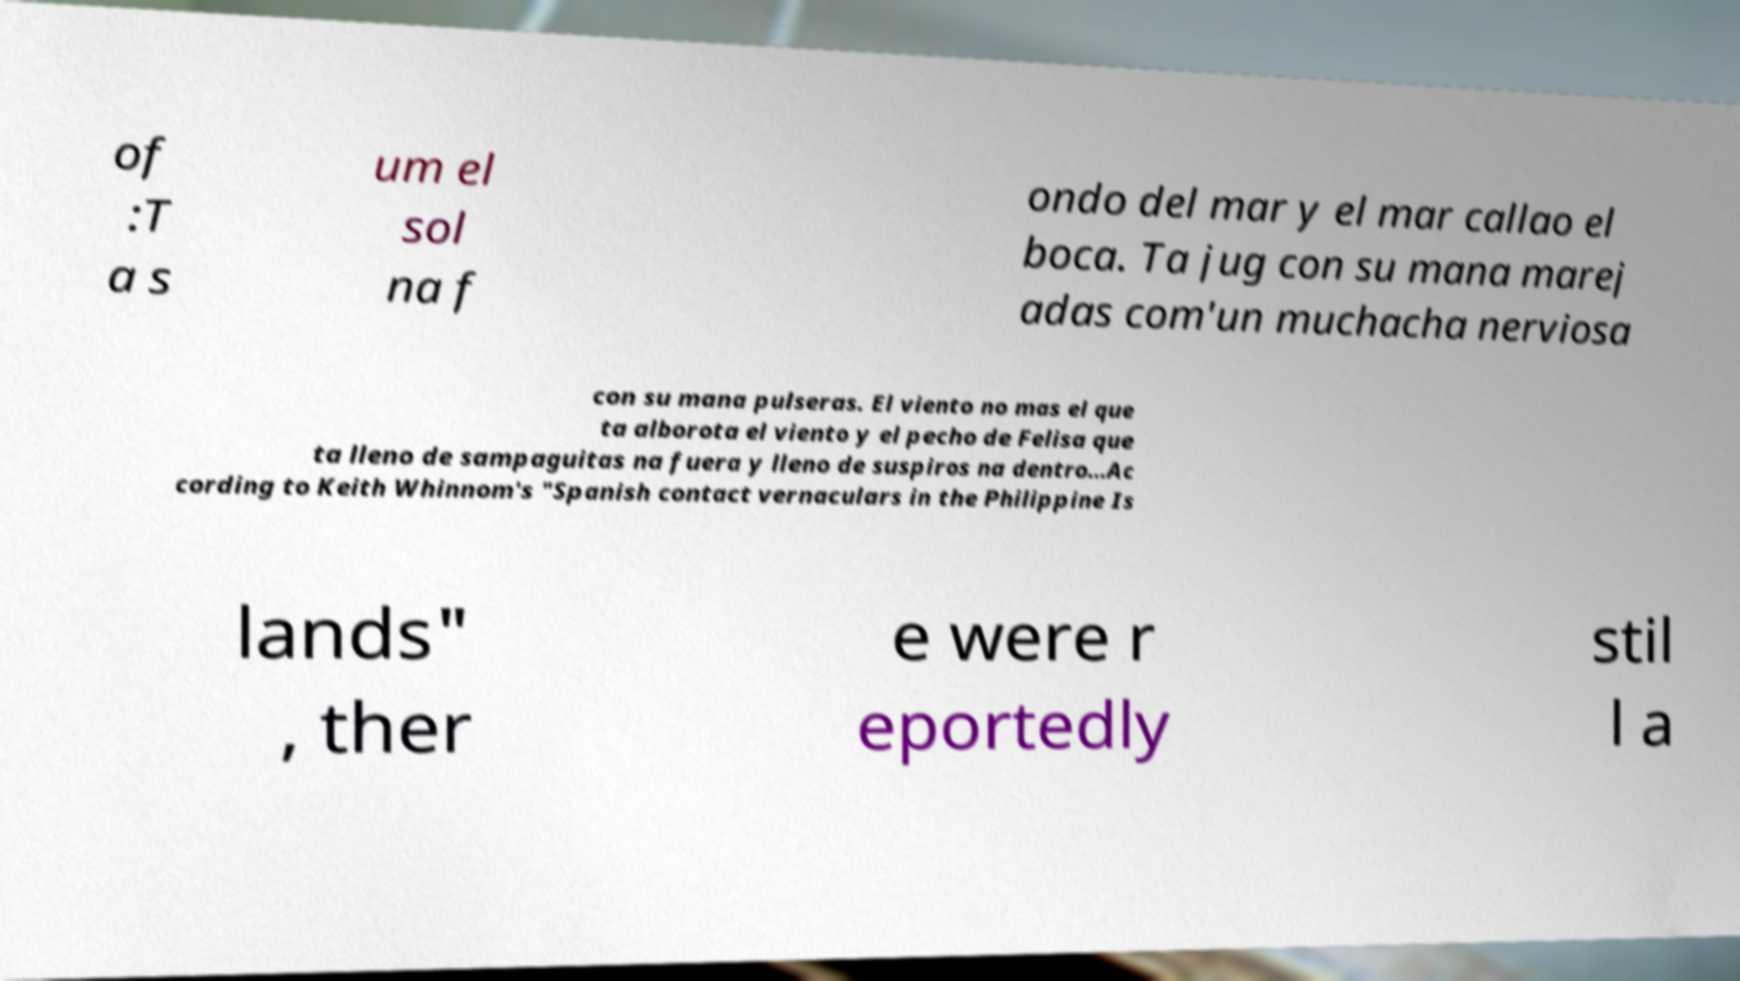Can you accurately transcribe the text from the provided image for me? of :T a s um el sol na f ondo del mar y el mar callao el boca. Ta jug con su mana marej adas com'un muchacha nerviosa con su mana pulseras. El viento no mas el que ta alborota el viento y el pecho de Felisa que ta lleno de sampaguitas na fuera y lleno de suspiros na dentro...Ac cording to Keith Whinnom's "Spanish contact vernaculars in the Philippine Is lands" , ther e were r eportedly stil l a 